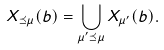<formula> <loc_0><loc_0><loc_500><loc_500>X _ { \preceq \mu } ( b ) = \bigcup _ { \mu ^ { \prime } \preceq \mu } X _ { \mu ^ { \prime } } ( b ) .</formula> 